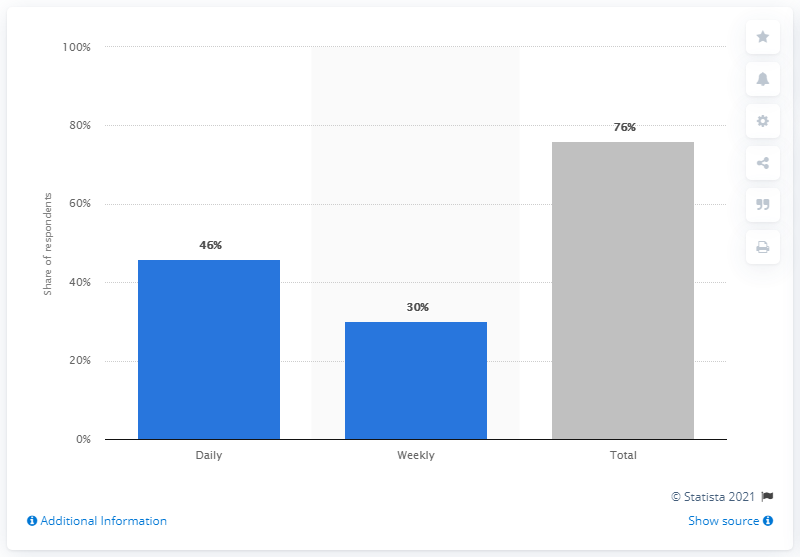Identify some key points in this picture. In 2017, Spotify had a daily user share of 46% in Finland. 